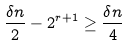Convert formula to latex. <formula><loc_0><loc_0><loc_500><loc_500>\frac { \delta n } { 2 } - 2 ^ { r + 1 } \geq \frac { \delta n } { 4 }</formula> 